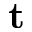<formula> <loc_0><loc_0><loc_500><loc_500>t</formula> 